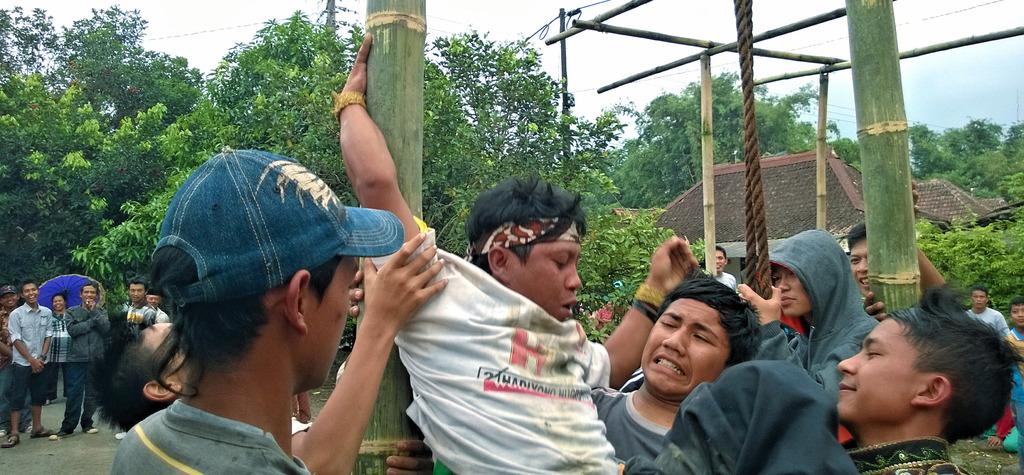What are the people in the image doing? The people in the image are performing an activity with bamboo sticks. How are the people in the image being observed? The crowd is watching the performance. What can be seen in the background of the image? There are trees and houses in the background of the image. Where is the grandmother sitting with a basket of oranges in the image? There is no grandmother or basket of oranges present in the image. What is the performer doing with their wrist during the performance? The provided facts do not mention any specific actions involving the wrist during the performance. 